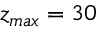<formula> <loc_0><loc_0><loc_500><loc_500>z _ { \max } = 3 0</formula> 